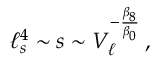Convert formula to latex. <formula><loc_0><loc_0><loc_500><loc_500>\ell _ { s } ^ { 4 } \sim s \sim V _ { \ell } ^ { - { \frac { \beta _ { 8 } } { \beta _ { 0 } } } } \, ,</formula> 